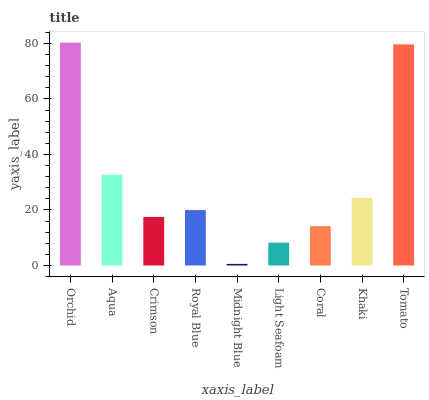Is Midnight Blue the minimum?
Answer yes or no. Yes. Is Orchid the maximum?
Answer yes or no. Yes. Is Aqua the minimum?
Answer yes or no. No. Is Aqua the maximum?
Answer yes or no. No. Is Orchid greater than Aqua?
Answer yes or no. Yes. Is Aqua less than Orchid?
Answer yes or no. Yes. Is Aqua greater than Orchid?
Answer yes or no. No. Is Orchid less than Aqua?
Answer yes or no. No. Is Royal Blue the high median?
Answer yes or no. Yes. Is Royal Blue the low median?
Answer yes or no. Yes. Is Khaki the high median?
Answer yes or no. No. Is Aqua the low median?
Answer yes or no. No. 